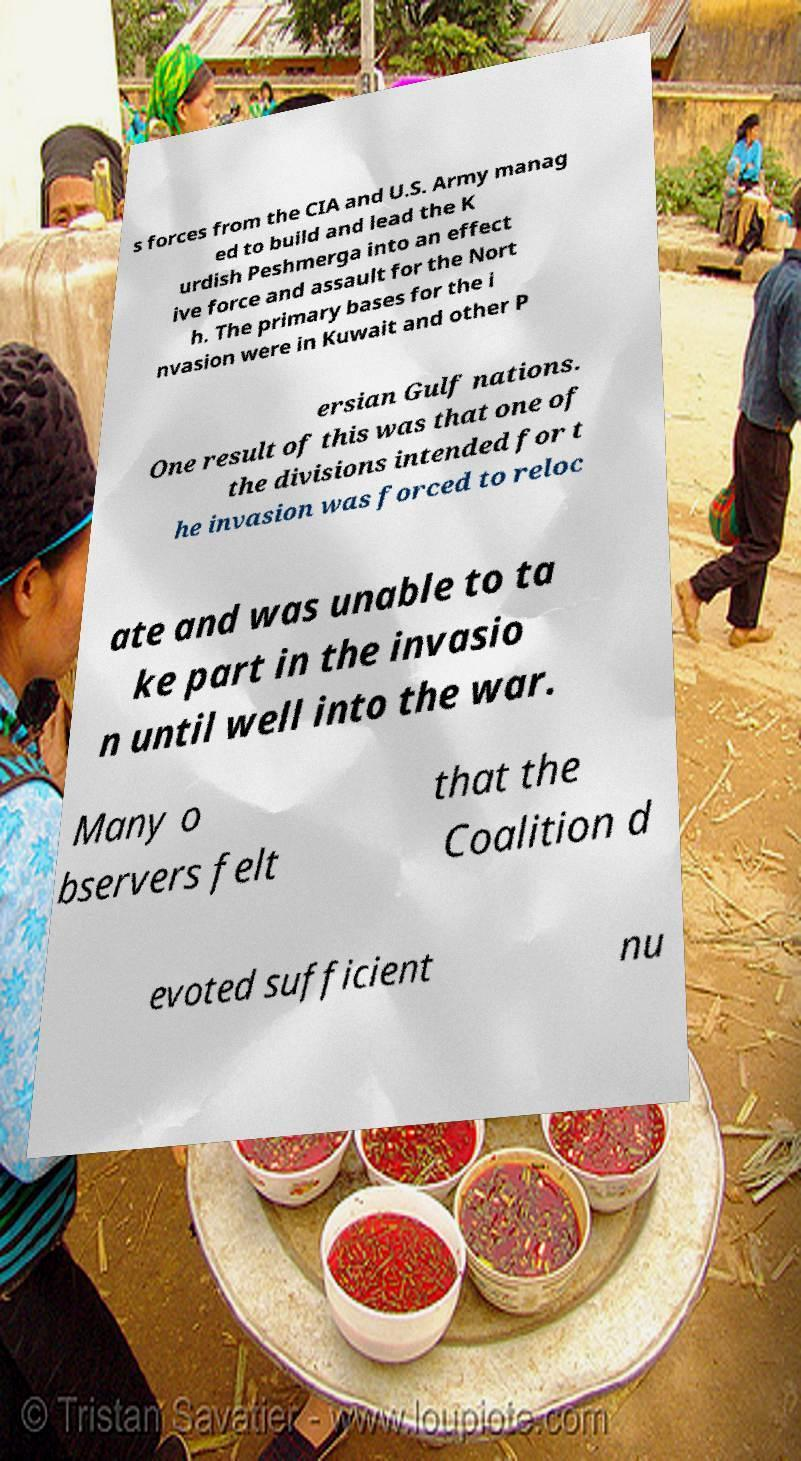Could you extract and type out the text from this image? s forces from the CIA and U.S. Army manag ed to build and lead the K urdish Peshmerga into an effect ive force and assault for the Nort h. The primary bases for the i nvasion were in Kuwait and other P ersian Gulf nations. One result of this was that one of the divisions intended for t he invasion was forced to reloc ate and was unable to ta ke part in the invasio n until well into the war. Many o bservers felt that the Coalition d evoted sufficient nu 